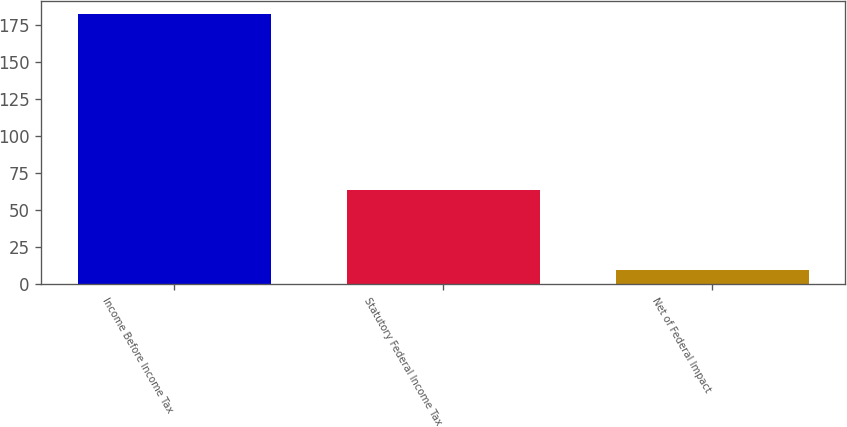Convert chart. <chart><loc_0><loc_0><loc_500><loc_500><bar_chart><fcel>Income Before Income Tax<fcel>Statutory Federal Income Tax<fcel>Net of Federal Impact<nl><fcel>182.5<fcel>63.9<fcel>9.6<nl></chart> 